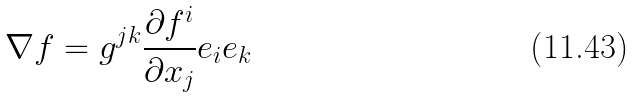Convert formula to latex. <formula><loc_0><loc_0><loc_500><loc_500>\nabla f = g ^ { j k } \frac { \partial f ^ { i } } { \partial x _ { j } } e _ { i } e _ { k }</formula> 